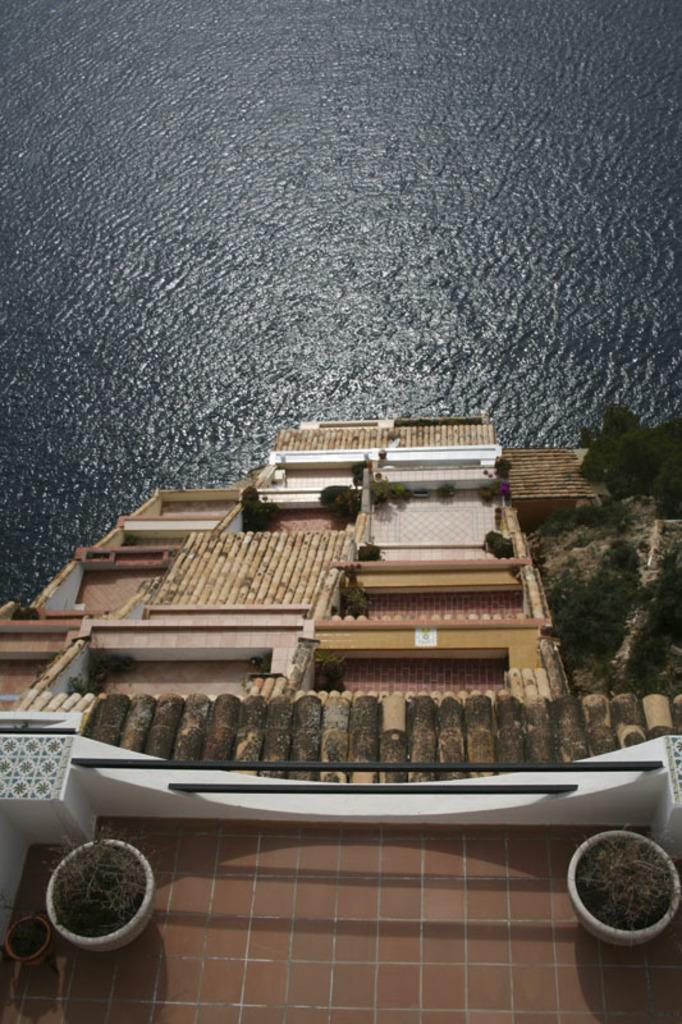What is the main structure visible in the image? There is a house in the front of the image. Are there any plants in the image? Yes, there are two plants in the image. What type of vegetation is on the right side of the image? There are trees on the right side of the image. What can be seen in the background of the image? There is water visible in the background of the image. What type of net can be seen in the image? There is no net present in the image. What song is being sung by the trees in the image? Trees do not sing songs, and there is no indication of any song in the image. 